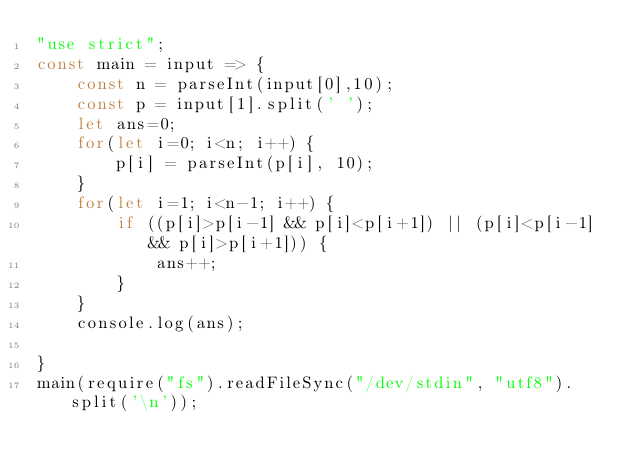<code> <loc_0><loc_0><loc_500><loc_500><_JavaScript_>"use strict";
const main = input => {
    const n = parseInt(input[0],10);
    const p = input[1].split(' ');
    let ans=0;
    for(let i=0; i<n; i++) {
        p[i] = parseInt(p[i], 10);
    }
    for(let i=1; i<n-1; i++) {
        if ((p[i]>p[i-1] && p[i]<p[i+1]) || (p[i]<p[i-1] && p[i]>p[i+1])) {
            ans++;
        }
    }
    console.log(ans);
    
}
main(require("fs").readFileSync("/dev/stdin", "utf8").split('\n'));</code> 